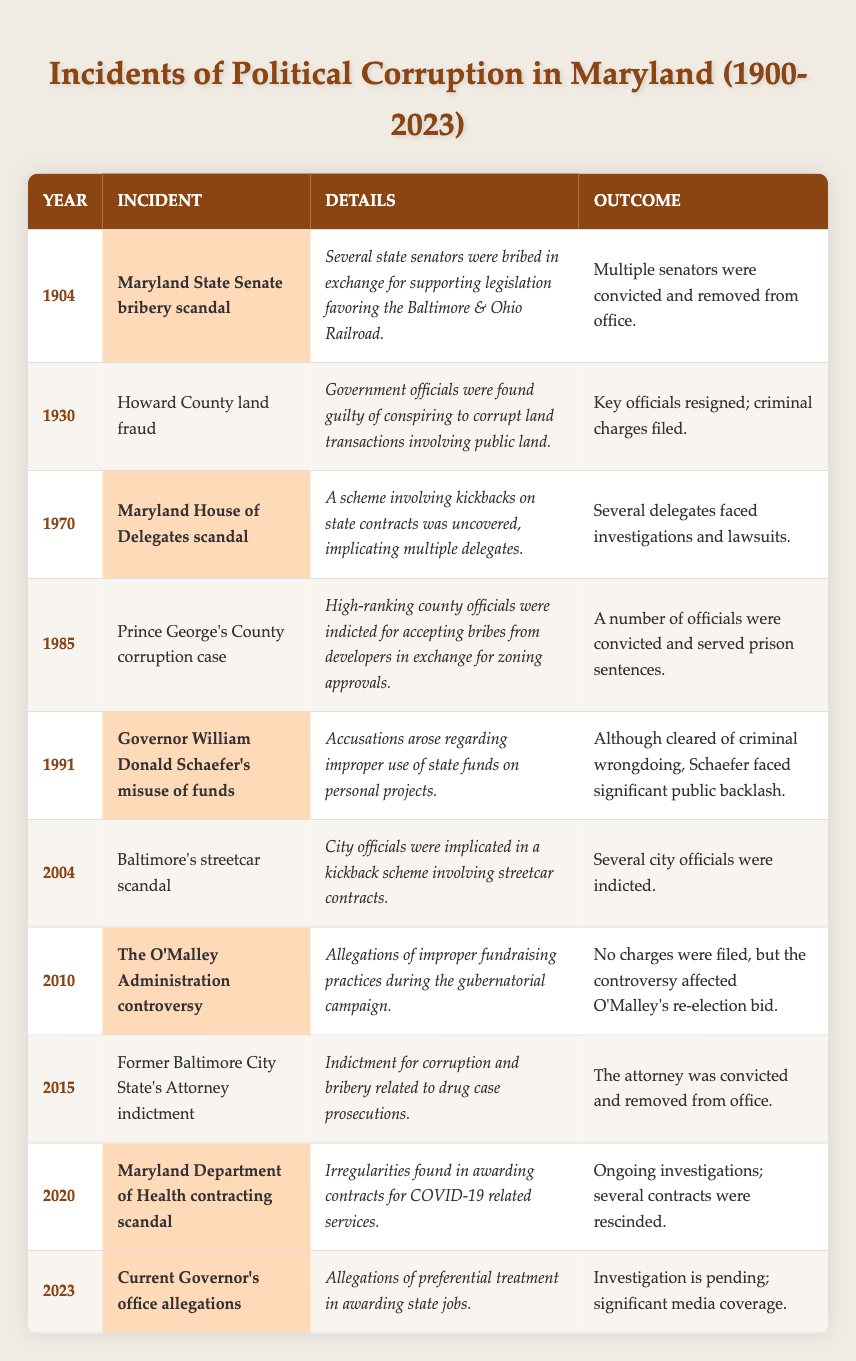What was the incident in 1904? The table lists the incident for the year 1904 as the "Maryland State Senate bribery scandal."
Answer: Maryland State Senate bribery scandal How many incidents occurred in the 2000s? The incidents from 2000 to 2023 are as follows: 2004 (Baltimore's streetcar scandal), 2010 (The O'Malley Administration controversy), 2015 (Former Baltimore City State's Attorney indictment), 2020 (Maryland Department of Health contracting scandal), and 2023 (Current Governor's office allegations), which totals 5 incidents.
Answer: 5 What was the outcome of the 1985 incident? The table indicates that the outcome of the 1985 Prince George's County corruption case was that several officials were convicted and served prison sentences.
Answer: Several officials were convicted and served prison sentences Did any incidents lead to a governor facing criminal charges? Referring to the table, it states that in 1991, Governor William Donald Schaefer was accused of misuse of funds but was cleared of criminal wrongdoing. Therefore, the answer is no.
Answer: No Which incident involved kickbacks on state contracts? The incident labeled "Maryland House of Delegates scandal" in 1970 involved kickbacks on state contracts.
Answer: Maryland House of Delegates scandal What was the most recent incident listed? The table shows that the most recent incident listed is from the year 2023, specifically "Current Governor's office allegations."
Answer: Current Governor's office allegations How many incidents were related to bribery according to the table? The incidents related to bribery are: the 1904 Maryland State Senate bribery scandal, the 1970 Maryland House of Delegates scandal, the 1985 Prince George's County corruption case, the 2015 Former Baltimore City State's Attorney indictment, and the 2004 Baltimore's streetcar scandal. This totals to 5 incidents.
Answer: 5 Which year had an incident of improper fundraising practices? The incident pertaining to improper fundraising practices occurred in 2010 during "The O'Malley Administration controversy."
Answer: 2010 Were there any incidences that led to investigations? By examining the table, it identifies multiple incidents that led to investigations: the 1970 Maryland House of Delegates scandal, 2004 Baltimore's streetcar scandal, 2015 Former Baltimore City State's Attorney indictment, and the 2020 Maryland Department of Health contracting scandal. Therefore, the answer is yes.
Answer: Yes What common theme can be deduced from incidents occurring every 25 years? Based on the table, incidents in the years 1904, 1930, 1970, and 1991 (which are approximately 25 years apart) all involved various forms of political corruption, such as bribery and misuse of funds.
Answer: Political corruption 